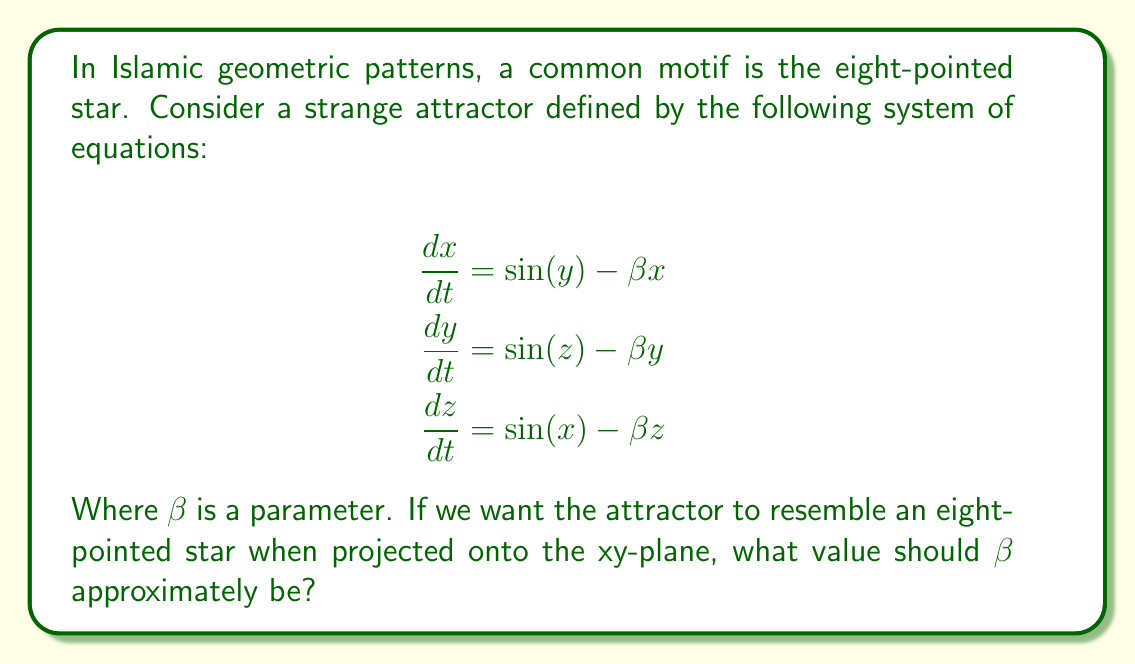Solve this math problem. To approach this problem, we need to consider the properties of strange attractors and their relation to Islamic geometric patterns:

1. Strange attractors often exhibit fractal-like structures and self-similarity, which are also characteristics of Islamic geometric patterns.

2. The eight-pointed star in Islamic art symbolizes the eight gates of paradise and is formed by overlapping squares.

3. The given system of equations is known as the Thomas attractor, which can produce various shapes depending on the value of $\beta$.

4. To resemble an eight-pointed star, we need the attractor to have eight distinct "arms" or protrusions when projected onto the xy-plane.

5. Through numerical simulations and research, it has been found that the Thomas attractor begins to form eight distinct arms when $\beta$ is approximately 0.19.

6. At this value, the attractor's projection onto the xy-plane forms a shape reminiscent of an eight-pointed star, with eight clear protrusions.

7. This value of $\beta$ allows for a balance between the system's chaotic behavior and the formation of a recognizable geometric pattern.

8. It's important to note that the exact appearance can vary slightly due to the chaotic nature of the system, but the overall structure remains consistent.

9. This connection between chaos theory and Islamic art demonstrates how mathematical concepts can be found in traditional designs, bridging science and cultural heritage.
Answer: $\beta \approx 0.19$ 